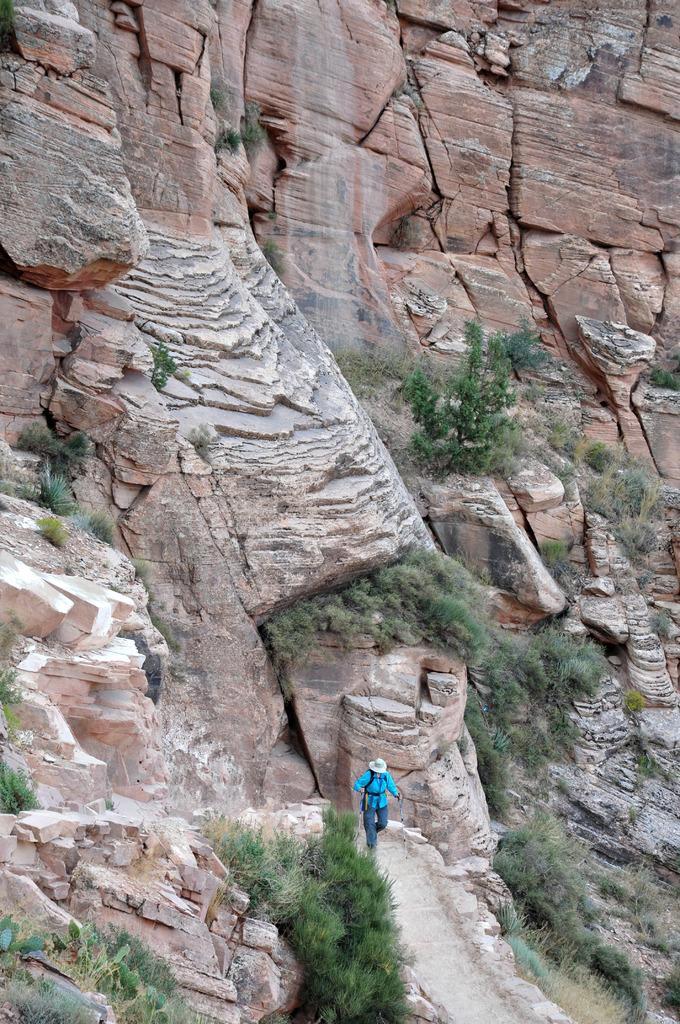Could you give a brief overview of what you see in this image? At the bottom of the image we can see a person and there are trees. In the background there are rocks. 